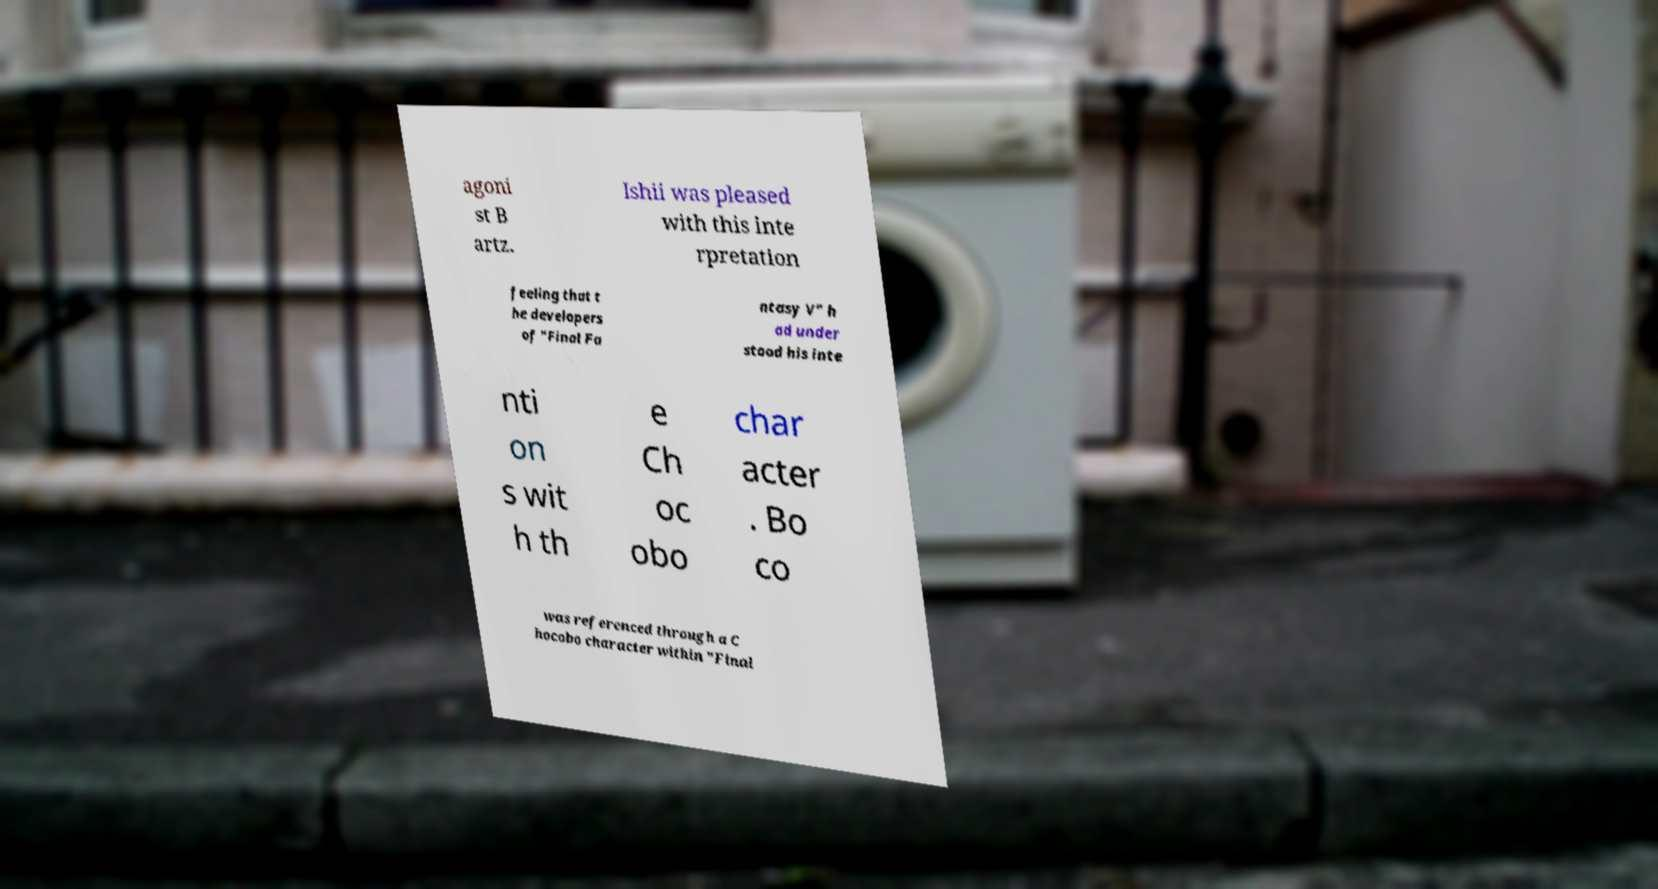Please identify and transcribe the text found in this image. agoni st B artz. Ishii was pleased with this inte rpretation feeling that t he developers of "Final Fa ntasy V" h ad under stood his inte nti on s wit h th e Ch oc obo char acter . Bo co was referenced through a C hocobo character within "Final 